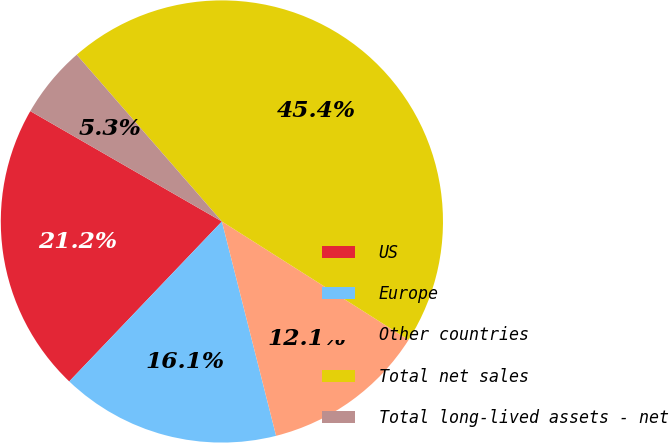Convert chart. <chart><loc_0><loc_0><loc_500><loc_500><pie_chart><fcel>US<fcel>Europe<fcel>Other countries<fcel>Total net sales<fcel>Total long-lived assets - net<nl><fcel>21.19%<fcel>16.07%<fcel>12.06%<fcel>45.4%<fcel>5.28%<nl></chart> 